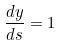Convert formula to latex. <formula><loc_0><loc_0><loc_500><loc_500>\frac { d y } { d s } = 1</formula> 